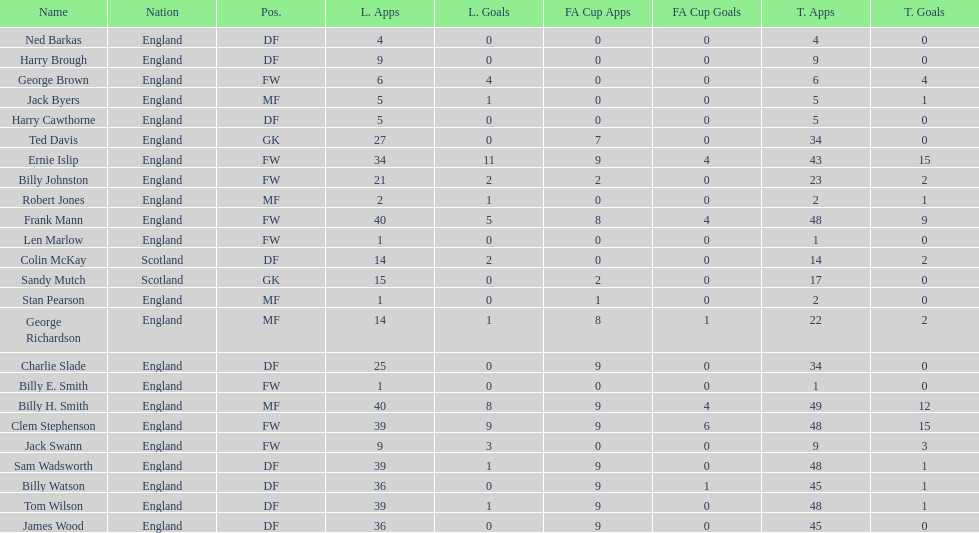Which position is listed the least amount of times on this chart? GK. 